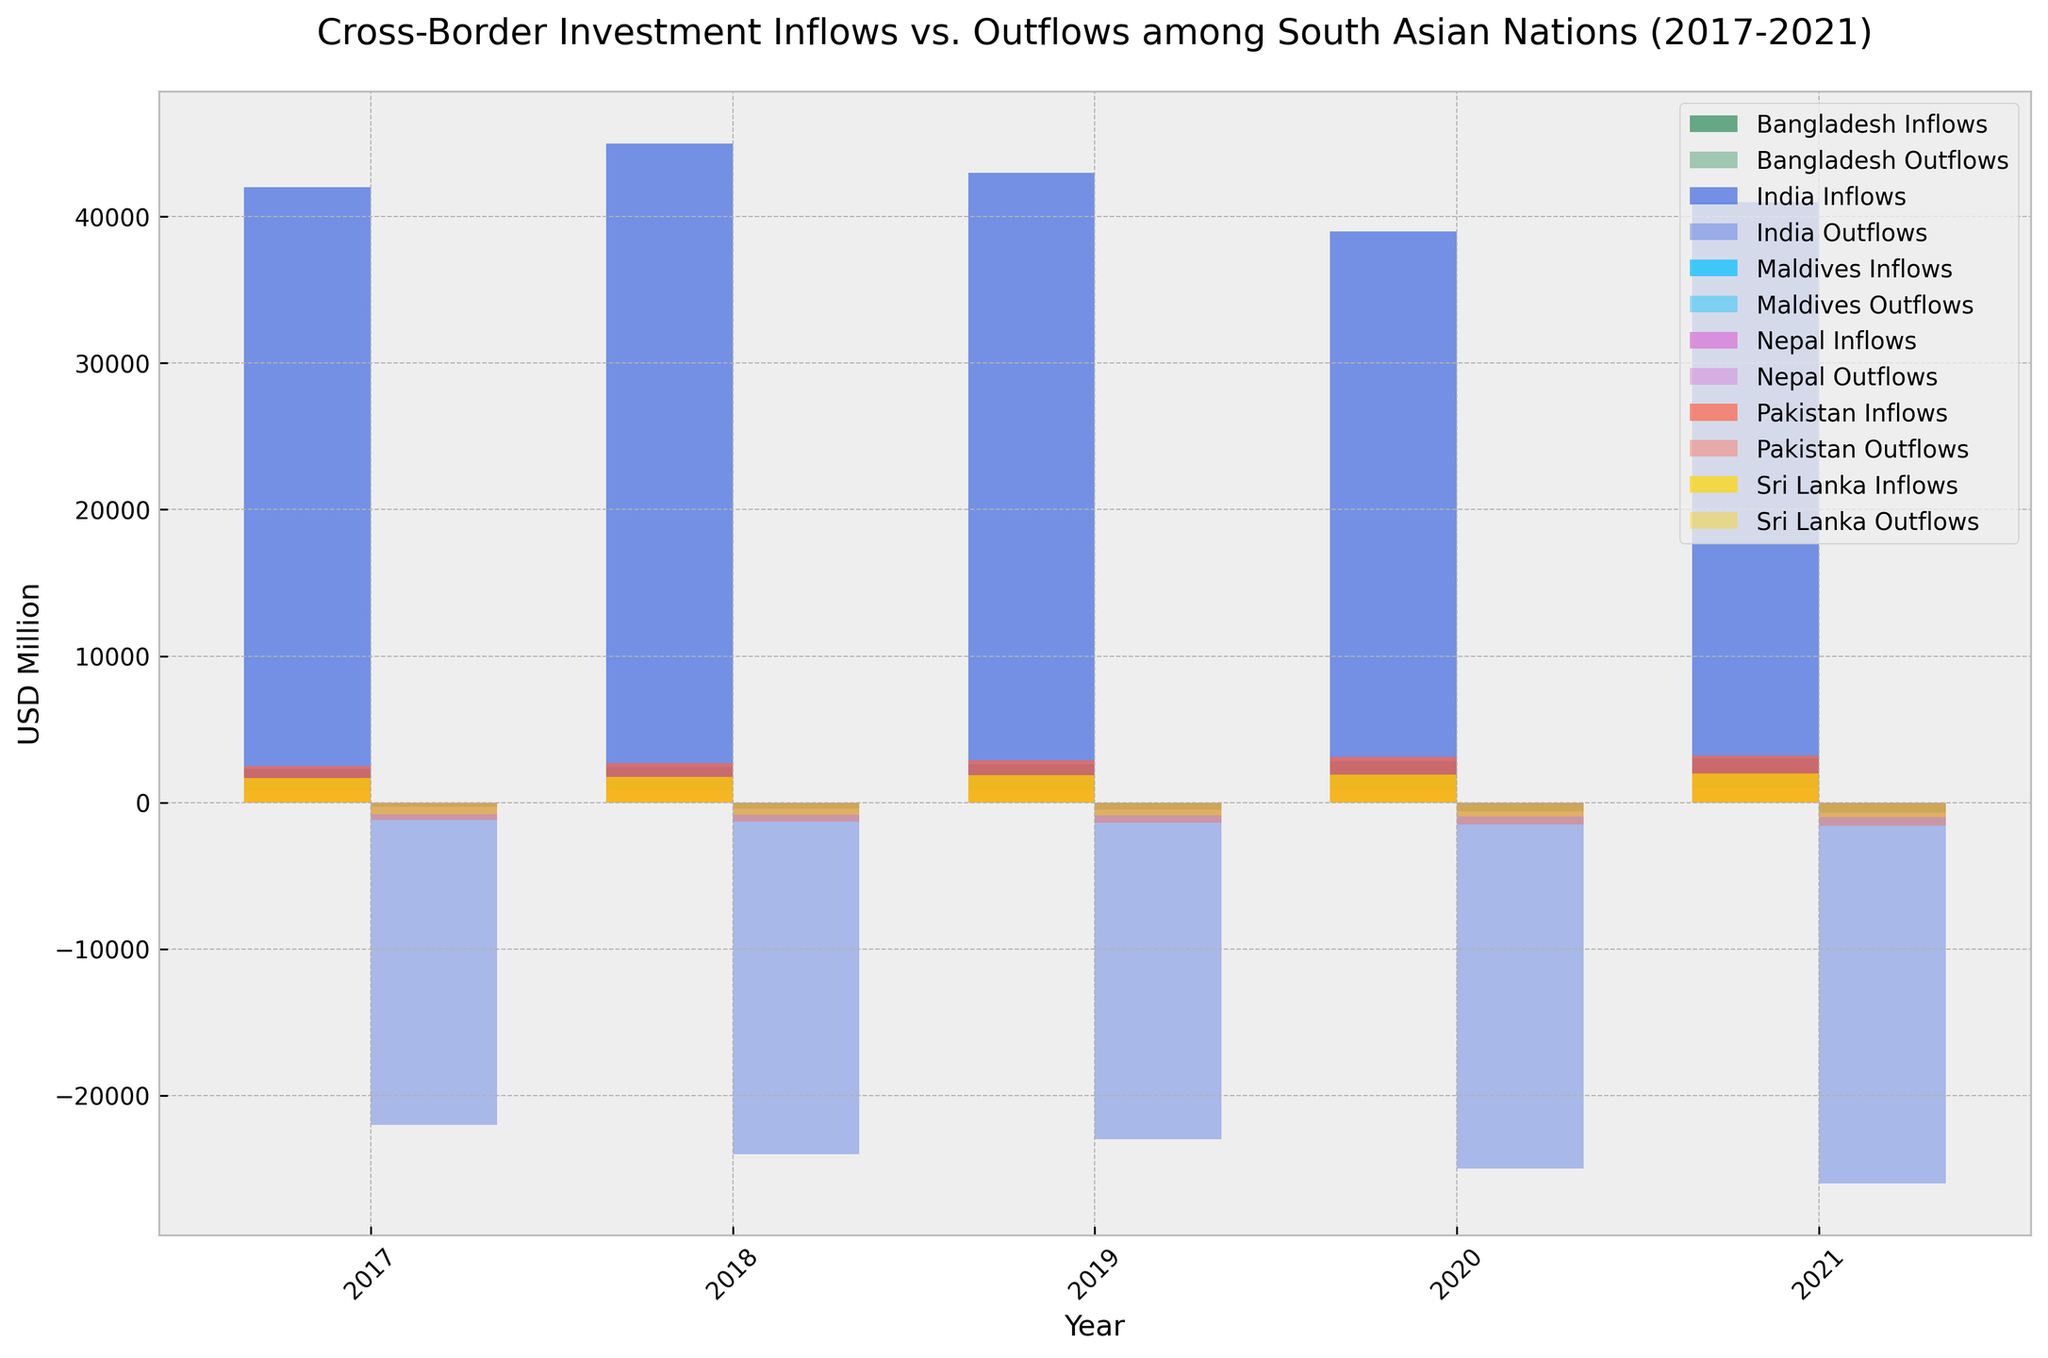What's the trend in India's investment inflows from 2017 to 2021? By observing the bars representing India's inflows, we see an overall slight decline from 2017 (42,000) to 2021 (41,000). Year by year, it increases until 2018, then declines until 2020, and rises again in 2021.
Answer: Overall slight decline, with ups and downs How do Pakistan's outflows compare to Bangladesh's outflows in 2021? By comparing the heights of the bars for outflows in 2021 for both countries, Pakistan's outflows are taller at -1600 while Bangladesh's are shorter at -700.
Answer: Pakistan's outflows are greater Which country had the highest investment inflows in 2020? By comparing the heights of all the inflow bars for 2020, India's bar is the tallest at 39,000.
Answer: India What is the average annual outflow for Sri Lanka from 2017 to 2021? Summing up Sri Lanka's outflows for each year: -800, -850, -900, -950, -1000 gives -4500. Dividing by the 5 years gives an average of -4500/5 = -900.
Answer: -900 By how much did Nepal's inflows increase from 2017 to 2021? In 2017, Nepal's inflows were 800, and in 2021, they were 950. The increase is 950 - 800 = 150.
Answer: 150 Which country had the lowest outflows in 2019? By comparing the heights of the outflow bars for 2019, Maldives' bar is the shortest at -170.
Answer: Maldives For which year did Bangladesh see the greatest increase in inflows compared to the previous year? Comparing the inflow bars year by year for Bangladesh, the largest increase is from 2018 (2400) to 2019 (2600), an increase of 200.
Answer: Between 2018 and 2019 Among the six countries, which had greater inflows than outflows in 2020? By observing the heights of inflow and outflow bars for each country in 2020, all countries (India, Pakistan, Bangladesh, Sri Lanka, Nepal, Maldives) have higher inflows (positive values) than outflows (negative values).
Answer: All six countries Which country's inflows were least affected during the selected period (2017-2021)? By analyzing the bar heights for inflows over the years, Nepal shows the least variation, with inflows ranging from 800 to 950.
Answer: Nepal What is the total investment outflow for Maldives over the five-year period? Summing up Maldives' outflows for each year: -150 (2017) + -160 (2018) + -170 (2019) + -180 (2020) + -190 (2021) = -850.
Answer: -850 